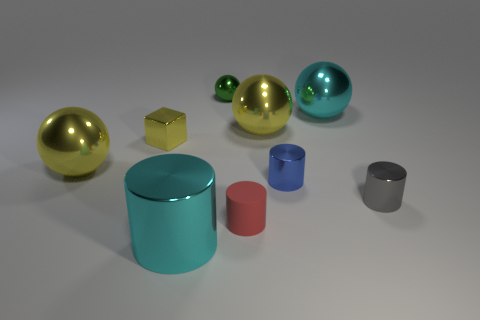Subtract all spheres. How many objects are left? 5 Add 5 large cyan cylinders. How many large cyan cylinders exist? 6 Subtract 1 cyan cylinders. How many objects are left? 8 Subtract all green things. Subtract all metal objects. How many objects are left? 0 Add 2 green metallic objects. How many green metallic objects are left? 3 